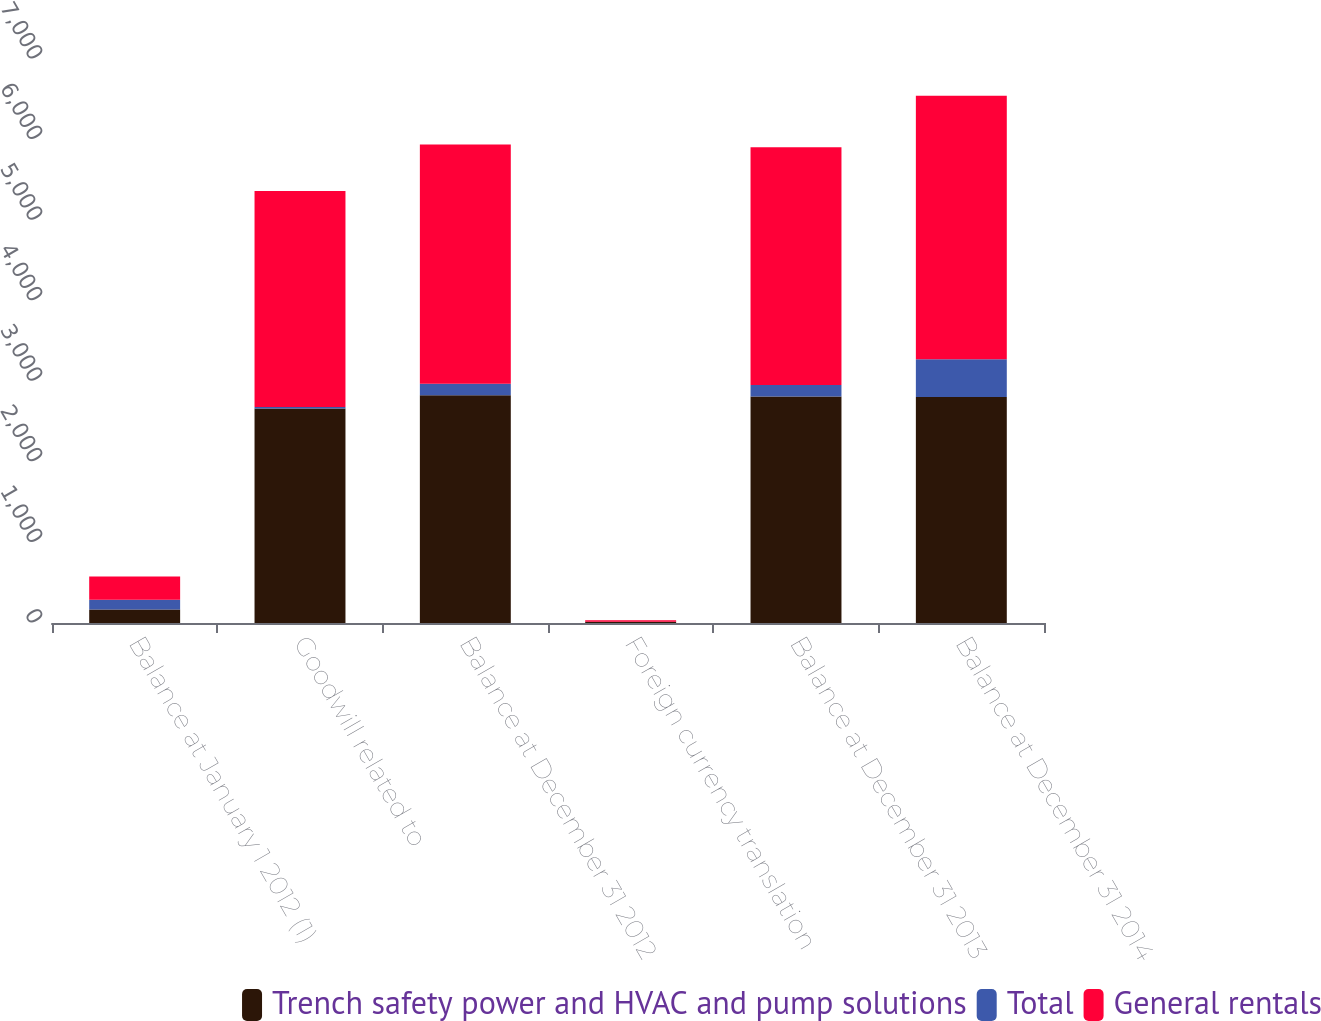Convert chart to OTSL. <chart><loc_0><loc_0><loc_500><loc_500><stacked_bar_chart><ecel><fcel>Balance at January 1 2012 (1)<fcel>Goodwill related to<fcel>Balance at December 31 2012<fcel>Foreign currency translation<fcel>Balance at December 31 2013<fcel>Balance at December 31 2014<nl><fcel>Trench safety power and HVAC and pump solutions<fcel>167<fcel>2661<fcel>2828<fcel>16<fcel>2812<fcel>2804<nl><fcel>Total<fcel>122<fcel>20<fcel>142<fcel>1<fcel>141<fcel>468<nl><fcel>General rentals<fcel>289<fcel>2681<fcel>2970<fcel>17<fcel>2953<fcel>3272<nl></chart> 